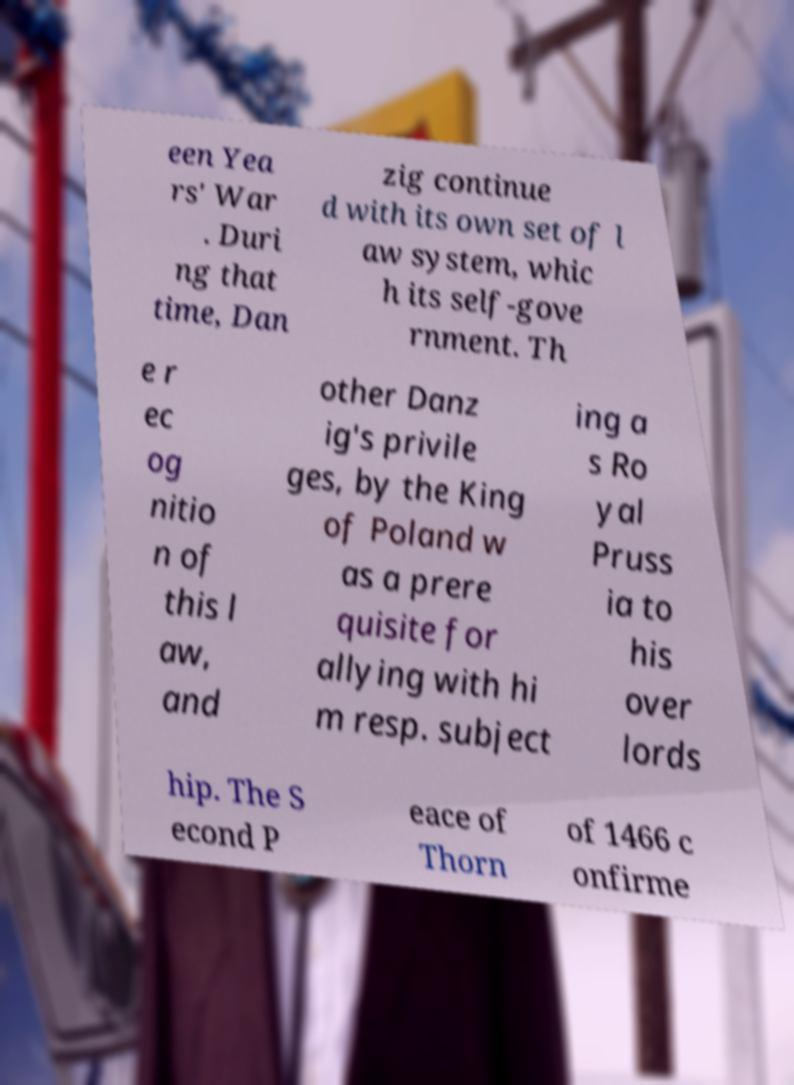Can you read and provide the text displayed in the image?This photo seems to have some interesting text. Can you extract and type it out for me? een Yea rs' War . Duri ng that time, Dan zig continue d with its own set of l aw system, whic h its self-gove rnment. Th e r ec og nitio n of this l aw, and other Danz ig's privile ges, by the King of Poland w as a prere quisite for allying with hi m resp. subject ing a s Ro yal Pruss ia to his over lords hip. The S econd P eace of Thorn of 1466 c onfirme 